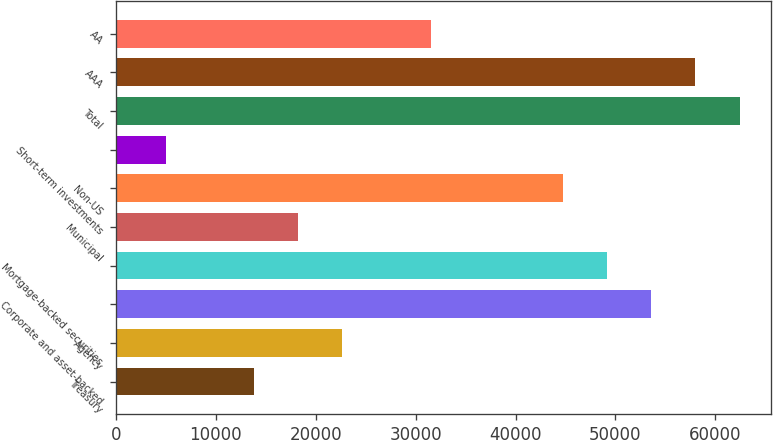<chart> <loc_0><loc_0><loc_500><loc_500><bar_chart><fcel>Treasury<fcel>Agency<fcel>Corporate and asset-backed<fcel>Mortgage-backed securities<fcel>Municipal<fcel>Non-US<fcel>Short-term investments<fcel>Total<fcel>AAA<fcel>AA<nl><fcel>13833.3<fcel>22667.5<fcel>53587.2<fcel>49170.1<fcel>18250.4<fcel>44753<fcel>4999.1<fcel>62421.4<fcel>58004.3<fcel>31501.7<nl></chart> 